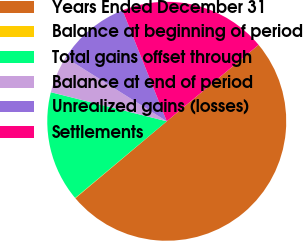<chart> <loc_0><loc_0><loc_500><loc_500><pie_chart><fcel>Years Ended December 31<fcel>Balance at beginning of period<fcel>Total gains offset through<fcel>Balance at end of period<fcel>Unrealized gains (losses)<fcel>Settlements<nl><fcel>49.9%<fcel>0.05%<fcel>15.0%<fcel>5.03%<fcel>10.02%<fcel>19.99%<nl></chart> 